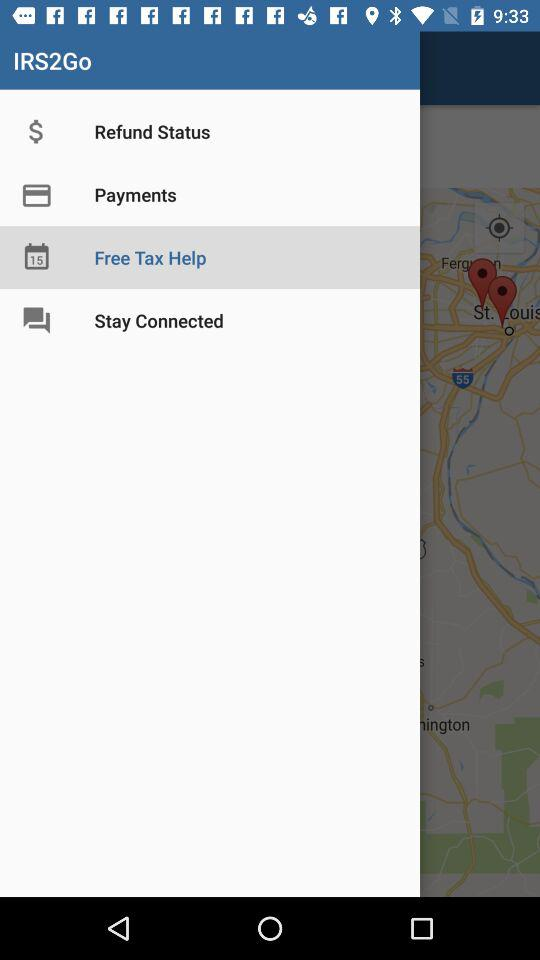What is the application name? The application name is "IRS2Go". 